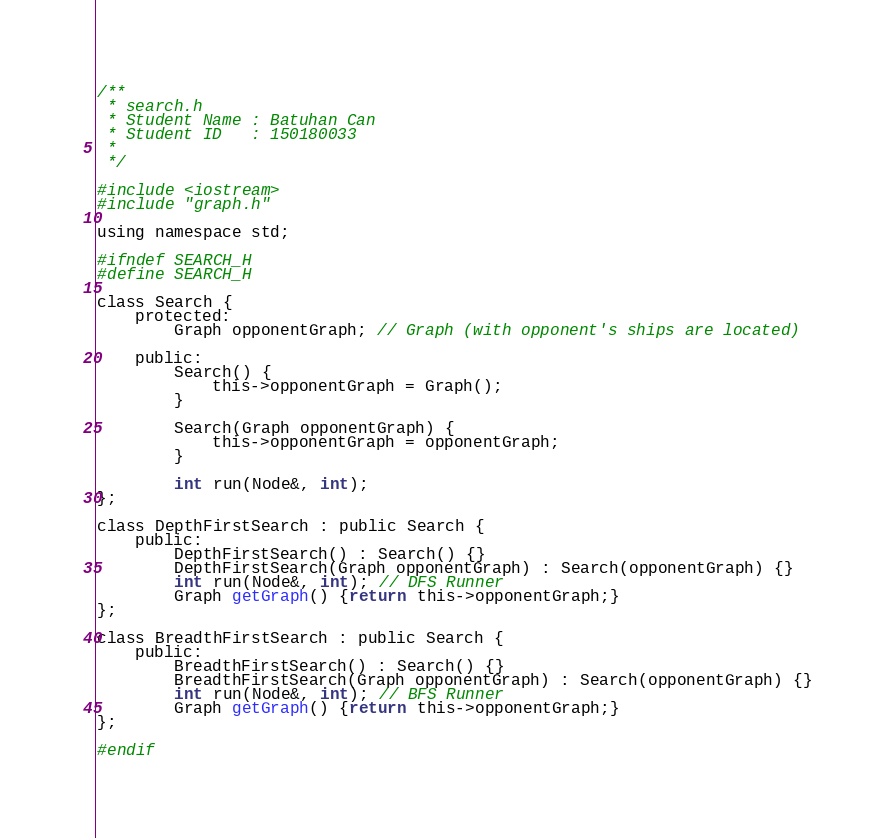<code> <loc_0><loc_0><loc_500><loc_500><_C_>/**
 * search.h
 * Student Name : Batuhan Can 
 * Student ID   : 150180033
 * 
 */

#include <iostream>
#include "graph.h"

using namespace std;

#ifndef SEARCH_H
#define SEARCH_H

class Search {
    protected:
        Graph opponentGraph; // Graph (with opponent's ships are located)

    public:
        Search() {
            this->opponentGraph = Graph();
        }

        Search(Graph opponentGraph) {
            this->opponentGraph = opponentGraph;
        }

        int run(Node&, int);
};

class DepthFirstSearch : public Search {
    public:
        DepthFirstSearch() : Search() {}
        DepthFirstSearch(Graph opponentGraph) : Search(opponentGraph) {}
        int run(Node&, int); // DFS Runner
        Graph getGraph() {return this->opponentGraph;}
};

class BreadthFirstSearch : public Search {
    public:
        BreadthFirstSearch() : Search() {}
        BreadthFirstSearch(Graph opponentGraph) : Search(opponentGraph) {}
        int run(Node&, int); // BFS Runner
        Graph getGraph() {return this->opponentGraph;}
};

#endif</code> 